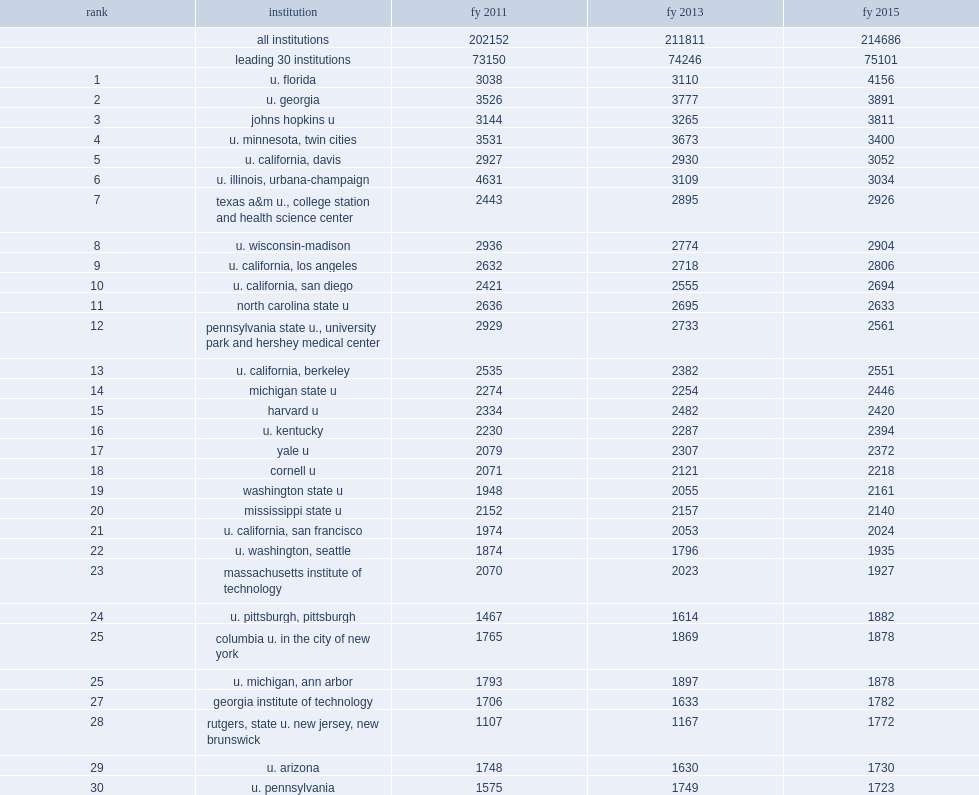Of the 570 institutions surveyed, how many percent did the top 30 institutions ranked by total s&e nasf account of all research space in fy 2015? 0.349818. The share is unchanged since fy 2013 and is less than the share in fy 2011, what is the share in fy 2011? 0.361856. 